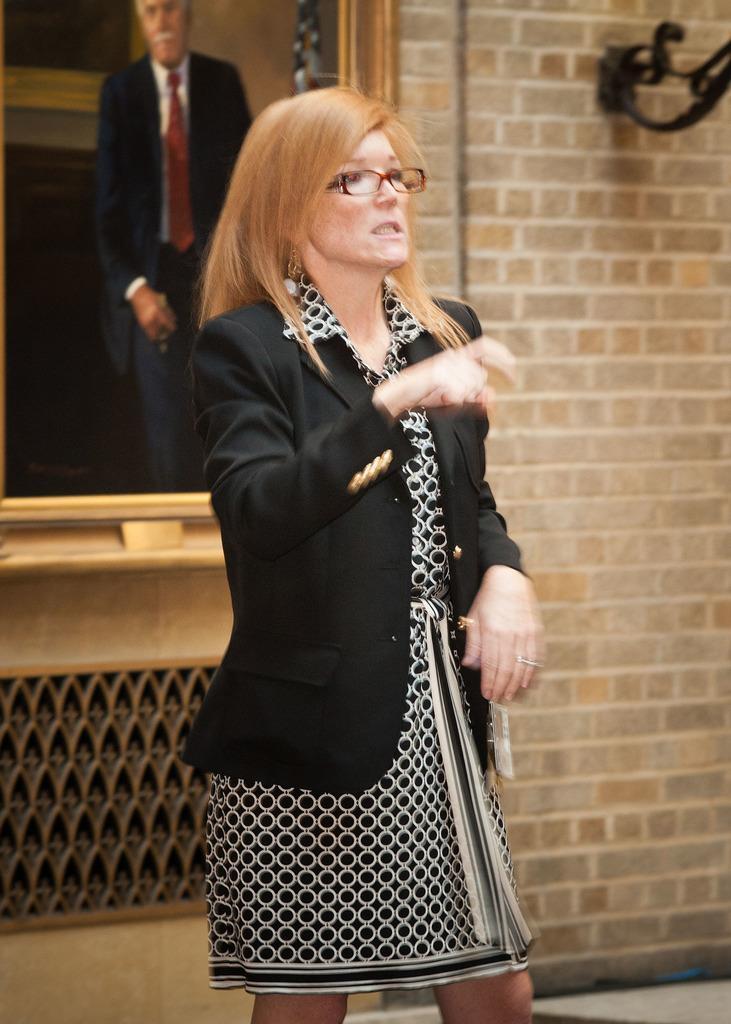In one or two sentences, can you explain what this image depicts? In this picture there is a woman who is wearing spectacle, blazer and dress. Behind her I can see a frame which is placed on the wall. In the frame I can see the man who is standing near to the flag and window. In the top right corner I can see the stand which is placed on the brick wall. 